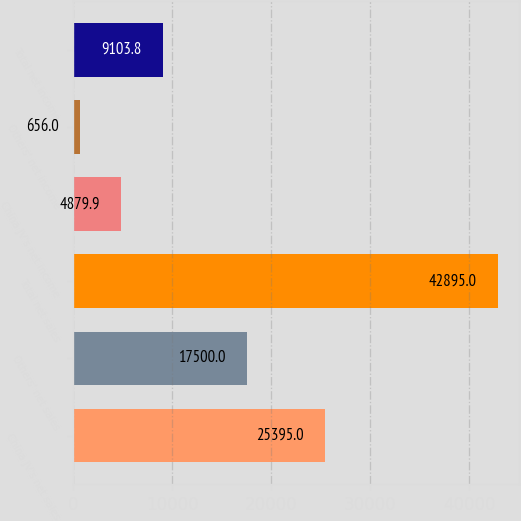<chart> <loc_0><loc_0><loc_500><loc_500><bar_chart><fcel>China JV's net sales<fcel>Others' net sales<fcel>Total net sales<fcel>China JV's net income<fcel>Others' net income<fcel>Total net income<nl><fcel>25395<fcel>17500<fcel>42895<fcel>4879.9<fcel>656<fcel>9103.8<nl></chart> 